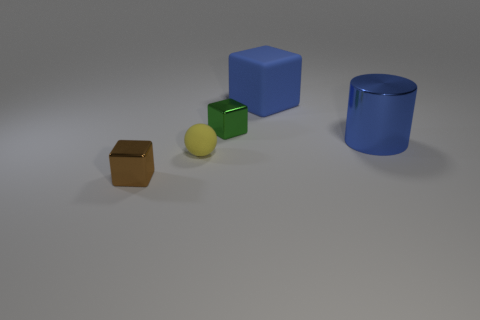What is the color of the matte cube that is the same size as the blue cylinder?
Provide a short and direct response. Blue. How many things are either shiny objects right of the rubber cube or metallic blocks behind the big metallic cylinder?
Make the answer very short. 2. Is the number of green cubes that are in front of the big blue cylinder the same as the number of tiny yellow shiny things?
Ensure brevity in your answer.  Yes. Is the size of the matte thing behind the yellow sphere the same as the matte object that is in front of the big blue matte thing?
Provide a succinct answer. No. What number of other objects are the same size as the blue shiny cylinder?
Your answer should be compact. 1. Are there any rubber blocks that are in front of the large blue thing in front of the large blue matte cube that is on the right side of the yellow object?
Offer a terse response. No. Is there any other thing of the same color as the metal cylinder?
Your response must be concise. Yes. How big is the metal object to the right of the small green shiny object?
Provide a short and direct response. Large. There is a thing on the right side of the object behind the tiny cube to the right of the brown thing; how big is it?
Make the answer very short. Large. The thing that is behind the shiny cube that is to the right of the brown metal cube is what color?
Provide a succinct answer. Blue. 